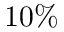<formula> <loc_0><loc_0><loc_500><loc_500>1 0 \%</formula> 